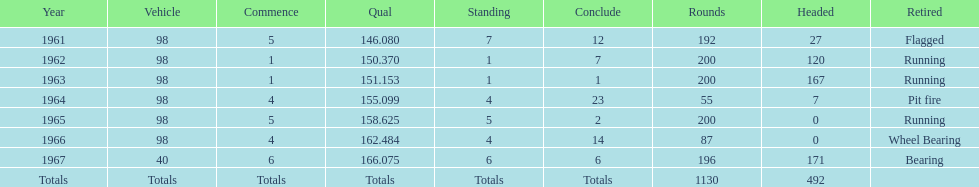What year(s) did parnelli finish at least 4th or better? 1963, 1965. 